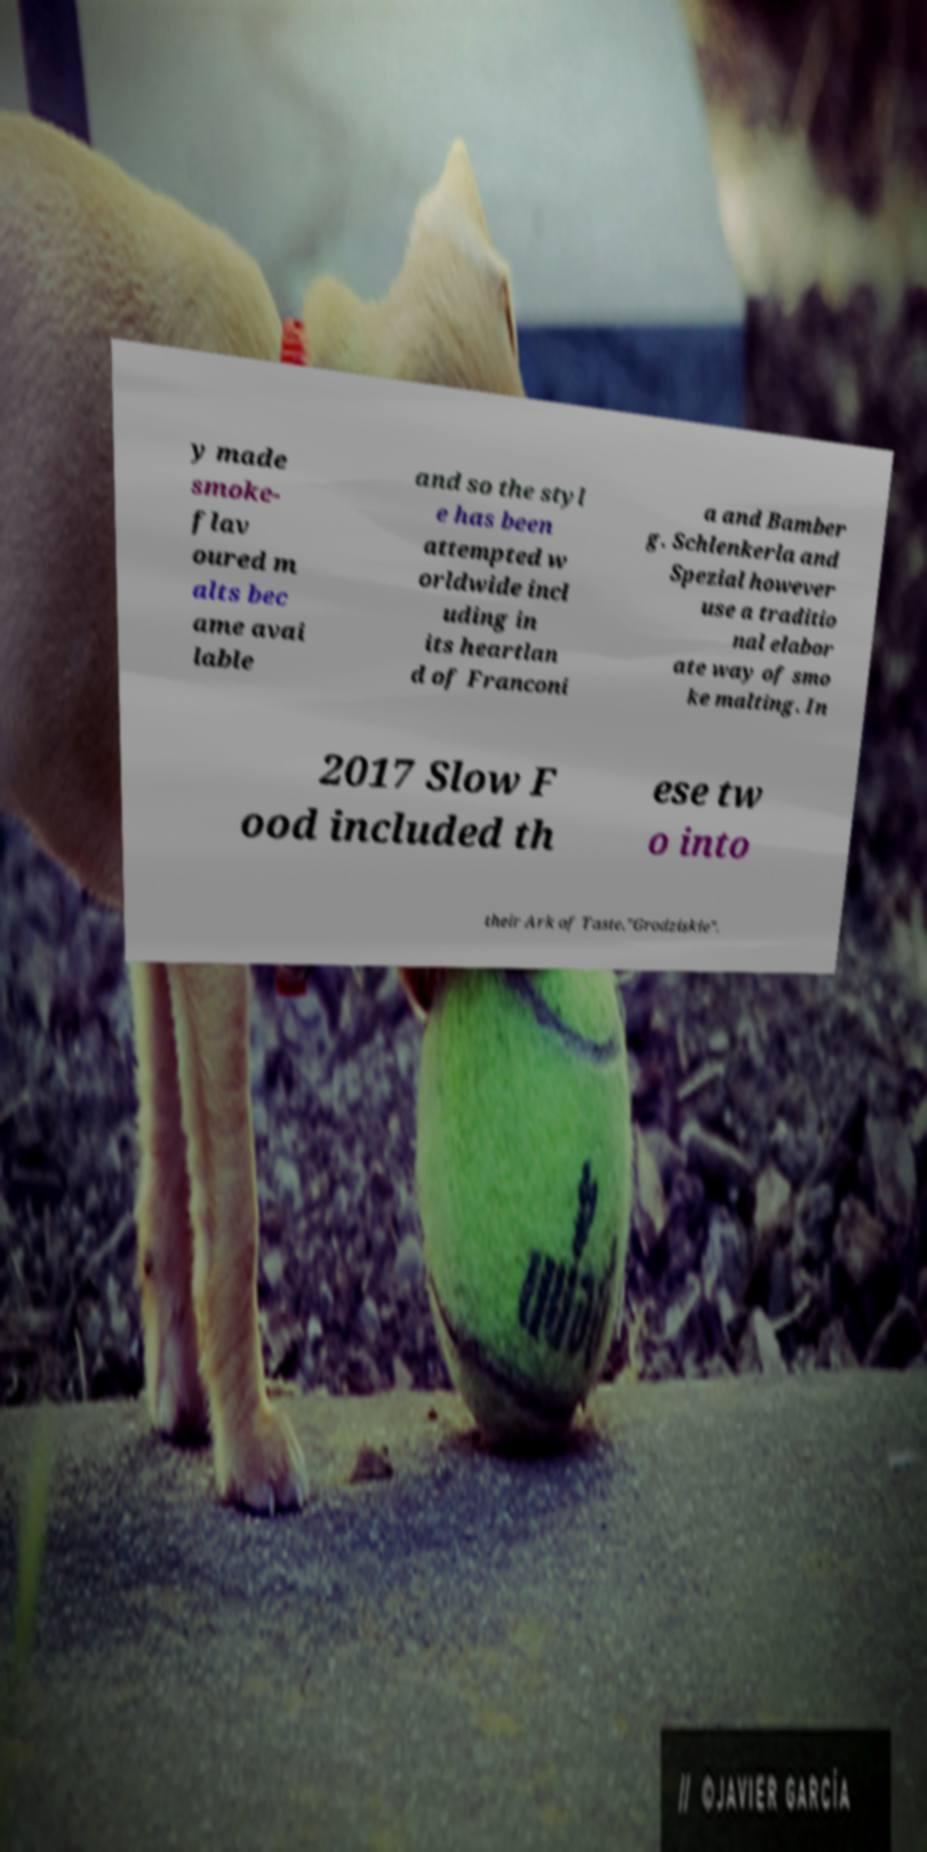Can you read and provide the text displayed in the image?This photo seems to have some interesting text. Can you extract and type it out for me? y made smoke- flav oured m alts bec ame avai lable and so the styl e has been attempted w orldwide incl uding in its heartlan d of Franconi a and Bamber g. Schlenkerla and Spezial however use a traditio nal elabor ate way of smo ke malting. In 2017 Slow F ood included th ese tw o into their Ark of Taste."Grodziskie". 